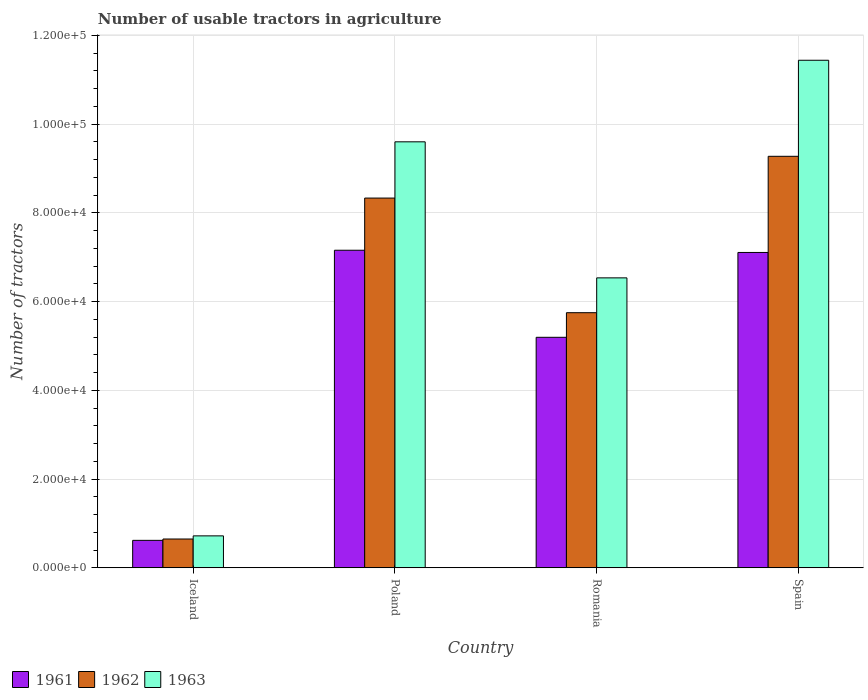What is the number of usable tractors in agriculture in 1963 in Iceland?
Ensure brevity in your answer.  7187. Across all countries, what is the maximum number of usable tractors in agriculture in 1963?
Your response must be concise. 1.14e+05. Across all countries, what is the minimum number of usable tractors in agriculture in 1962?
Provide a short and direct response. 6479. In which country was the number of usable tractors in agriculture in 1961 maximum?
Make the answer very short. Poland. What is the total number of usable tractors in agriculture in 1961 in the graph?
Provide a short and direct response. 2.01e+05. What is the difference between the number of usable tractors in agriculture in 1963 in Poland and that in Spain?
Keep it short and to the point. -1.84e+04. What is the difference between the number of usable tractors in agriculture in 1962 in Poland and the number of usable tractors in agriculture in 1961 in Iceland?
Provide a short and direct response. 7.72e+04. What is the average number of usable tractors in agriculture in 1961 per country?
Your answer should be very brief. 5.02e+04. What is the difference between the number of usable tractors in agriculture of/in 1963 and number of usable tractors in agriculture of/in 1962 in Romania?
Ensure brevity in your answer.  7851. In how many countries, is the number of usable tractors in agriculture in 1963 greater than 100000?
Your response must be concise. 1. What is the ratio of the number of usable tractors in agriculture in 1963 in Romania to that in Spain?
Your answer should be compact. 0.57. Is the number of usable tractors in agriculture in 1962 in Iceland less than that in Poland?
Offer a terse response. Yes. Is the difference between the number of usable tractors in agriculture in 1963 in Poland and Romania greater than the difference between the number of usable tractors in agriculture in 1962 in Poland and Romania?
Make the answer very short. Yes. What is the difference between the highest and the second highest number of usable tractors in agriculture in 1962?
Your answer should be very brief. 3.53e+04. What is the difference between the highest and the lowest number of usable tractors in agriculture in 1963?
Provide a succinct answer. 1.07e+05. In how many countries, is the number of usable tractors in agriculture in 1962 greater than the average number of usable tractors in agriculture in 1962 taken over all countries?
Your answer should be compact. 2. Is the sum of the number of usable tractors in agriculture in 1961 in Iceland and Poland greater than the maximum number of usable tractors in agriculture in 1962 across all countries?
Your answer should be very brief. No. What does the 3rd bar from the left in Spain represents?
Offer a terse response. 1963. Is it the case that in every country, the sum of the number of usable tractors in agriculture in 1961 and number of usable tractors in agriculture in 1963 is greater than the number of usable tractors in agriculture in 1962?
Provide a short and direct response. Yes. How many bars are there?
Keep it short and to the point. 12. Are all the bars in the graph horizontal?
Offer a terse response. No. Are the values on the major ticks of Y-axis written in scientific E-notation?
Your answer should be very brief. Yes. How are the legend labels stacked?
Ensure brevity in your answer.  Horizontal. What is the title of the graph?
Your response must be concise. Number of usable tractors in agriculture. What is the label or title of the X-axis?
Provide a short and direct response. Country. What is the label or title of the Y-axis?
Provide a succinct answer. Number of tractors. What is the Number of tractors in 1961 in Iceland?
Your response must be concise. 6177. What is the Number of tractors in 1962 in Iceland?
Offer a very short reply. 6479. What is the Number of tractors of 1963 in Iceland?
Your answer should be compact. 7187. What is the Number of tractors of 1961 in Poland?
Offer a terse response. 7.16e+04. What is the Number of tractors of 1962 in Poland?
Give a very brief answer. 8.33e+04. What is the Number of tractors of 1963 in Poland?
Offer a terse response. 9.60e+04. What is the Number of tractors in 1961 in Romania?
Provide a succinct answer. 5.20e+04. What is the Number of tractors in 1962 in Romania?
Offer a terse response. 5.75e+04. What is the Number of tractors in 1963 in Romania?
Provide a short and direct response. 6.54e+04. What is the Number of tractors of 1961 in Spain?
Provide a succinct answer. 7.11e+04. What is the Number of tractors in 1962 in Spain?
Keep it short and to the point. 9.28e+04. What is the Number of tractors in 1963 in Spain?
Give a very brief answer. 1.14e+05. Across all countries, what is the maximum Number of tractors in 1961?
Ensure brevity in your answer.  7.16e+04. Across all countries, what is the maximum Number of tractors of 1962?
Offer a very short reply. 9.28e+04. Across all countries, what is the maximum Number of tractors in 1963?
Give a very brief answer. 1.14e+05. Across all countries, what is the minimum Number of tractors in 1961?
Your answer should be compact. 6177. Across all countries, what is the minimum Number of tractors of 1962?
Keep it short and to the point. 6479. Across all countries, what is the minimum Number of tractors in 1963?
Provide a succinct answer. 7187. What is the total Number of tractors of 1961 in the graph?
Offer a very short reply. 2.01e+05. What is the total Number of tractors in 1962 in the graph?
Give a very brief answer. 2.40e+05. What is the total Number of tractors in 1963 in the graph?
Your response must be concise. 2.83e+05. What is the difference between the Number of tractors in 1961 in Iceland and that in Poland?
Offer a terse response. -6.54e+04. What is the difference between the Number of tractors in 1962 in Iceland and that in Poland?
Offer a very short reply. -7.69e+04. What is the difference between the Number of tractors in 1963 in Iceland and that in Poland?
Your answer should be very brief. -8.88e+04. What is the difference between the Number of tractors in 1961 in Iceland and that in Romania?
Keep it short and to the point. -4.58e+04. What is the difference between the Number of tractors in 1962 in Iceland and that in Romania?
Your response must be concise. -5.10e+04. What is the difference between the Number of tractors of 1963 in Iceland and that in Romania?
Give a very brief answer. -5.82e+04. What is the difference between the Number of tractors in 1961 in Iceland and that in Spain?
Keep it short and to the point. -6.49e+04. What is the difference between the Number of tractors in 1962 in Iceland and that in Spain?
Make the answer very short. -8.63e+04. What is the difference between the Number of tractors of 1963 in Iceland and that in Spain?
Your response must be concise. -1.07e+05. What is the difference between the Number of tractors of 1961 in Poland and that in Romania?
Your answer should be very brief. 1.96e+04. What is the difference between the Number of tractors in 1962 in Poland and that in Romania?
Provide a succinct answer. 2.58e+04. What is the difference between the Number of tractors in 1963 in Poland and that in Romania?
Provide a short and direct response. 3.07e+04. What is the difference between the Number of tractors of 1962 in Poland and that in Spain?
Ensure brevity in your answer.  -9414. What is the difference between the Number of tractors of 1963 in Poland and that in Spain?
Offer a terse response. -1.84e+04. What is the difference between the Number of tractors of 1961 in Romania and that in Spain?
Keep it short and to the point. -1.91e+04. What is the difference between the Number of tractors in 1962 in Romania and that in Spain?
Provide a short and direct response. -3.53e+04. What is the difference between the Number of tractors in 1963 in Romania and that in Spain?
Keep it short and to the point. -4.91e+04. What is the difference between the Number of tractors of 1961 in Iceland and the Number of tractors of 1962 in Poland?
Offer a very short reply. -7.72e+04. What is the difference between the Number of tractors of 1961 in Iceland and the Number of tractors of 1963 in Poland?
Keep it short and to the point. -8.98e+04. What is the difference between the Number of tractors of 1962 in Iceland and the Number of tractors of 1963 in Poland?
Offer a terse response. -8.95e+04. What is the difference between the Number of tractors in 1961 in Iceland and the Number of tractors in 1962 in Romania?
Provide a succinct answer. -5.13e+04. What is the difference between the Number of tractors of 1961 in Iceland and the Number of tractors of 1963 in Romania?
Your answer should be compact. -5.92e+04. What is the difference between the Number of tractors of 1962 in Iceland and the Number of tractors of 1963 in Romania?
Make the answer very short. -5.89e+04. What is the difference between the Number of tractors in 1961 in Iceland and the Number of tractors in 1962 in Spain?
Your response must be concise. -8.66e+04. What is the difference between the Number of tractors in 1961 in Iceland and the Number of tractors in 1963 in Spain?
Keep it short and to the point. -1.08e+05. What is the difference between the Number of tractors in 1962 in Iceland and the Number of tractors in 1963 in Spain?
Provide a succinct answer. -1.08e+05. What is the difference between the Number of tractors in 1961 in Poland and the Number of tractors in 1962 in Romania?
Keep it short and to the point. 1.41e+04. What is the difference between the Number of tractors in 1961 in Poland and the Number of tractors in 1963 in Romania?
Offer a very short reply. 6226. What is the difference between the Number of tractors of 1962 in Poland and the Number of tractors of 1963 in Romania?
Provide a succinct answer. 1.80e+04. What is the difference between the Number of tractors of 1961 in Poland and the Number of tractors of 1962 in Spain?
Offer a terse response. -2.12e+04. What is the difference between the Number of tractors of 1961 in Poland and the Number of tractors of 1963 in Spain?
Keep it short and to the point. -4.28e+04. What is the difference between the Number of tractors in 1962 in Poland and the Number of tractors in 1963 in Spain?
Offer a terse response. -3.11e+04. What is the difference between the Number of tractors of 1961 in Romania and the Number of tractors of 1962 in Spain?
Provide a short and direct response. -4.08e+04. What is the difference between the Number of tractors in 1961 in Romania and the Number of tractors in 1963 in Spain?
Keep it short and to the point. -6.25e+04. What is the difference between the Number of tractors of 1962 in Romania and the Number of tractors of 1963 in Spain?
Your answer should be very brief. -5.69e+04. What is the average Number of tractors in 1961 per country?
Your response must be concise. 5.02e+04. What is the average Number of tractors in 1962 per country?
Offer a terse response. 6.00e+04. What is the average Number of tractors in 1963 per country?
Ensure brevity in your answer.  7.07e+04. What is the difference between the Number of tractors in 1961 and Number of tractors in 1962 in Iceland?
Your answer should be compact. -302. What is the difference between the Number of tractors in 1961 and Number of tractors in 1963 in Iceland?
Your answer should be very brief. -1010. What is the difference between the Number of tractors in 1962 and Number of tractors in 1963 in Iceland?
Offer a very short reply. -708. What is the difference between the Number of tractors of 1961 and Number of tractors of 1962 in Poland?
Your answer should be compact. -1.18e+04. What is the difference between the Number of tractors of 1961 and Number of tractors of 1963 in Poland?
Provide a short and direct response. -2.44e+04. What is the difference between the Number of tractors of 1962 and Number of tractors of 1963 in Poland?
Offer a terse response. -1.27e+04. What is the difference between the Number of tractors of 1961 and Number of tractors of 1962 in Romania?
Ensure brevity in your answer.  -5548. What is the difference between the Number of tractors of 1961 and Number of tractors of 1963 in Romania?
Your answer should be very brief. -1.34e+04. What is the difference between the Number of tractors in 1962 and Number of tractors in 1963 in Romania?
Provide a succinct answer. -7851. What is the difference between the Number of tractors of 1961 and Number of tractors of 1962 in Spain?
Provide a succinct answer. -2.17e+04. What is the difference between the Number of tractors of 1961 and Number of tractors of 1963 in Spain?
Your response must be concise. -4.33e+04. What is the difference between the Number of tractors in 1962 and Number of tractors in 1963 in Spain?
Make the answer very short. -2.17e+04. What is the ratio of the Number of tractors in 1961 in Iceland to that in Poland?
Keep it short and to the point. 0.09. What is the ratio of the Number of tractors of 1962 in Iceland to that in Poland?
Ensure brevity in your answer.  0.08. What is the ratio of the Number of tractors of 1963 in Iceland to that in Poland?
Your answer should be compact. 0.07. What is the ratio of the Number of tractors of 1961 in Iceland to that in Romania?
Ensure brevity in your answer.  0.12. What is the ratio of the Number of tractors of 1962 in Iceland to that in Romania?
Ensure brevity in your answer.  0.11. What is the ratio of the Number of tractors in 1963 in Iceland to that in Romania?
Your response must be concise. 0.11. What is the ratio of the Number of tractors of 1961 in Iceland to that in Spain?
Keep it short and to the point. 0.09. What is the ratio of the Number of tractors in 1962 in Iceland to that in Spain?
Your answer should be compact. 0.07. What is the ratio of the Number of tractors in 1963 in Iceland to that in Spain?
Keep it short and to the point. 0.06. What is the ratio of the Number of tractors in 1961 in Poland to that in Romania?
Provide a short and direct response. 1.38. What is the ratio of the Number of tractors in 1962 in Poland to that in Romania?
Give a very brief answer. 1.45. What is the ratio of the Number of tractors of 1963 in Poland to that in Romania?
Offer a terse response. 1.47. What is the ratio of the Number of tractors of 1961 in Poland to that in Spain?
Your answer should be very brief. 1.01. What is the ratio of the Number of tractors of 1962 in Poland to that in Spain?
Keep it short and to the point. 0.9. What is the ratio of the Number of tractors of 1963 in Poland to that in Spain?
Your answer should be very brief. 0.84. What is the ratio of the Number of tractors of 1961 in Romania to that in Spain?
Make the answer very short. 0.73. What is the ratio of the Number of tractors of 1962 in Romania to that in Spain?
Provide a succinct answer. 0.62. What is the ratio of the Number of tractors in 1963 in Romania to that in Spain?
Your response must be concise. 0.57. What is the difference between the highest and the second highest Number of tractors of 1962?
Offer a terse response. 9414. What is the difference between the highest and the second highest Number of tractors of 1963?
Offer a terse response. 1.84e+04. What is the difference between the highest and the lowest Number of tractors in 1961?
Provide a short and direct response. 6.54e+04. What is the difference between the highest and the lowest Number of tractors in 1962?
Your answer should be very brief. 8.63e+04. What is the difference between the highest and the lowest Number of tractors in 1963?
Your answer should be compact. 1.07e+05. 